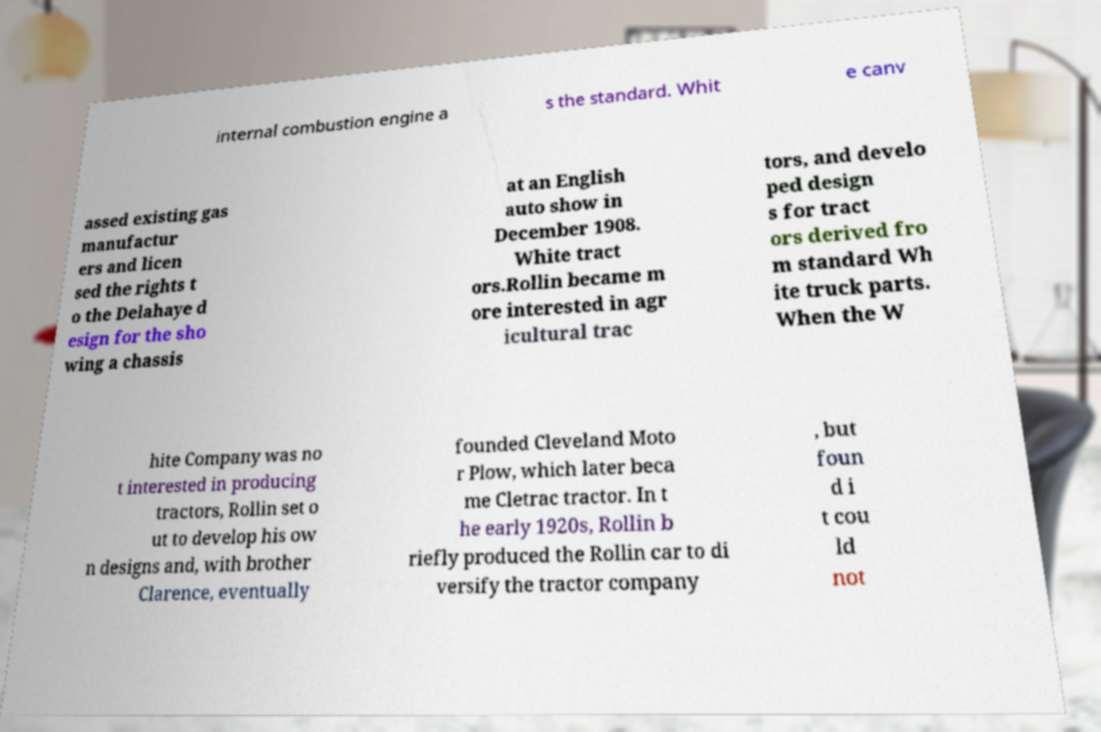Please identify and transcribe the text found in this image. internal combustion engine a s the standard. Whit e canv assed existing gas manufactur ers and licen sed the rights t o the Delahaye d esign for the sho wing a chassis at an English auto show in December 1908. White tract ors.Rollin became m ore interested in agr icultural trac tors, and develo ped design s for tract ors derived fro m standard Wh ite truck parts. When the W hite Company was no t interested in producing tractors, Rollin set o ut to develop his ow n designs and, with brother Clarence, eventually founded Cleveland Moto r Plow, which later beca me Cletrac tractor. In t he early 1920s, Rollin b riefly produced the Rollin car to di versify the tractor company , but foun d i t cou ld not 